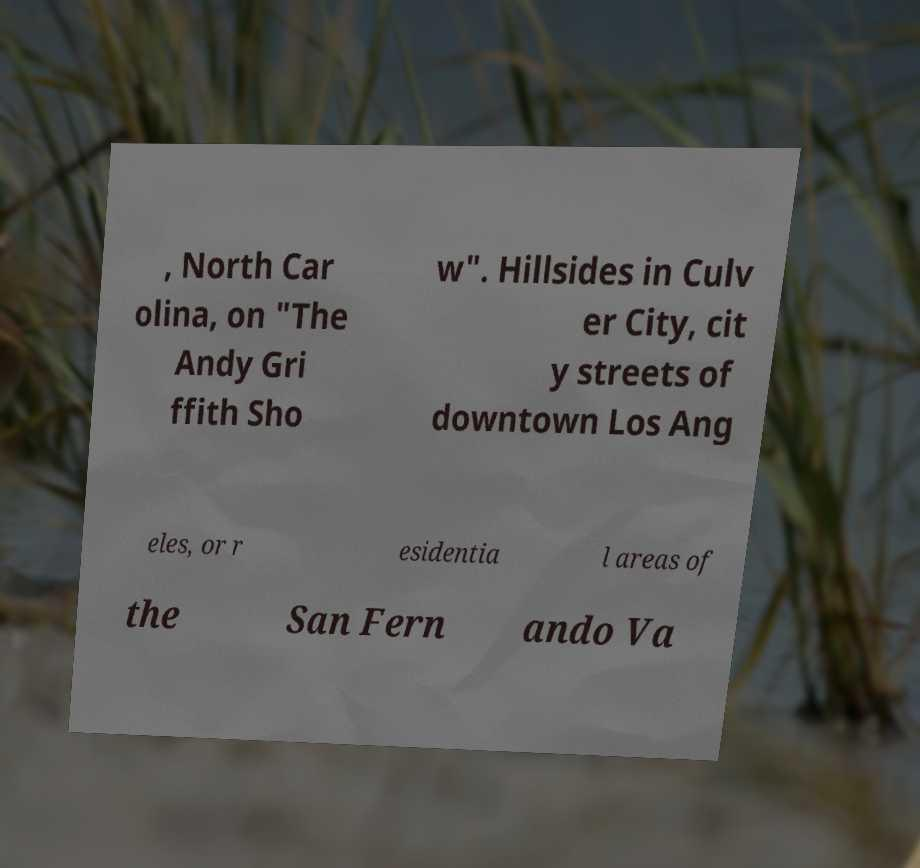Can you accurately transcribe the text from the provided image for me? , North Car olina, on "The Andy Gri ffith Sho w". Hillsides in Culv er City, cit y streets of downtown Los Ang eles, or r esidentia l areas of the San Fern ando Va 